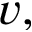<formula> <loc_0><loc_0><loc_500><loc_500>v ,</formula> 